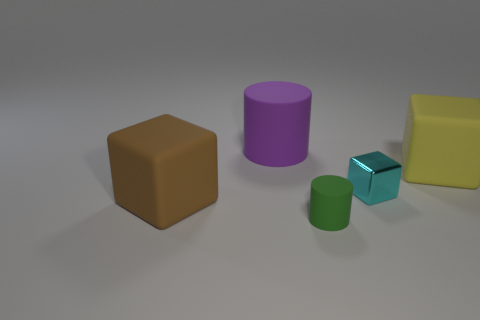Subtract all large cubes. How many cubes are left? 1 Add 4 cyan rubber cylinders. How many objects exist? 9 Subtract all blocks. How many objects are left? 2 Add 4 green metal cubes. How many green metal cubes exist? 4 Subtract 0 red cylinders. How many objects are left? 5 Subtract all brown blocks. Subtract all gray cylinders. How many blocks are left? 2 Subtract all tiny green cylinders. Subtract all tiny rubber cylinders. How many objects are left? 3 Add 5 green matte cylinders. How many green matte cylinders are left? 6 